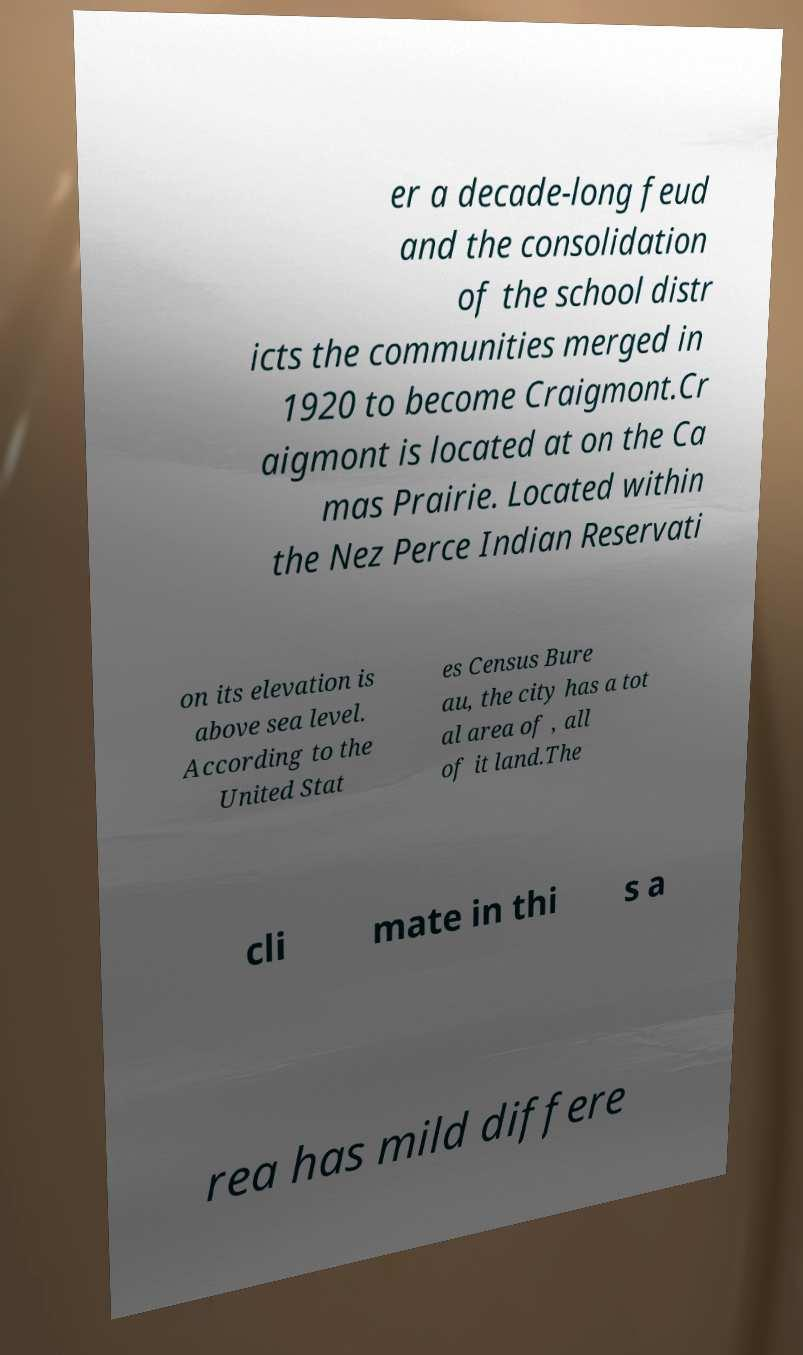Please identify and transcribe the text found in this image. er a decade-long feud and the consolidation of the school distr icts the communities merged in 1920 to become Craigmont.Cr aigmont is located at on the Ca mas Prairie. Located within the Nez Perce Indian Reservati on its elevation is above sea level. According to the United Stat es Census Bure au, the city has a tot al area of , all of it land.The cli mate in thi s a rea has mild differe 